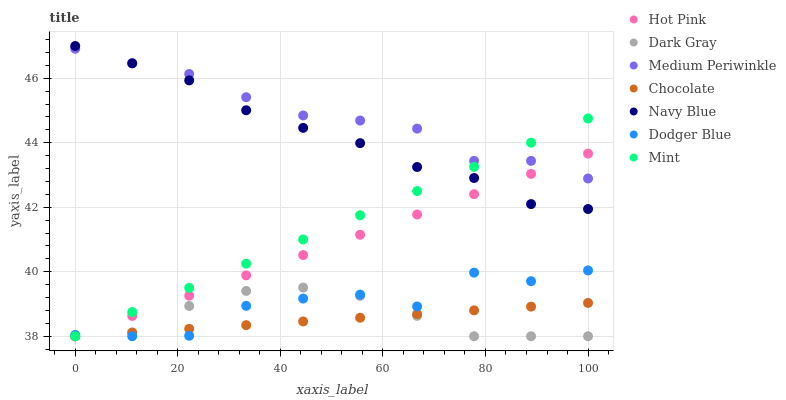Does Chocolate have the minimum area under the curve?
Answer yes or no. Yes. Does Medium Periwinkle have the maximum area under the curve?
Answer yes or no. Yes. Does Hot Pink have the minimum area under the curve?
Answer yes or no. No. Does Hot Pink have the maximum area under the curve?
Answer yes or no. No. Is Chocolate the smoothest?
Answer yes or no. Yes. Is Dodger Blue the roughest?
Answer yes or no. Yes. Is Hot Pink the smoothest?
Answer yes or no. No. Is Hot Pink the roughest?
Answer yes or no. No. Does Hot Pink have the lowest value?
Answer yes or no. Yes. Does Medium Periwinkle have the lowest value?
Answer yes or no. No. Does Navy Blue have the highest value?
Answer yes or no. Yes. Does Hot Pink have the highest value?
Answer yes or no. No. Is Dark Gray less than Medium Periwinkle?
Answer yes or no. Yes. Is Medium Periwinkle greater than Chocolate?
Answer yes or no. Yes. Does Navy Blue intersect Medium Periwinkle?
Answer yes or no. Yes. Is Navy Blue less than Medium Periwinkle?
Answer yes or no. No. Is Navy Blue greater than Medium Periwinkle?
Answer yes or no. No. Does Dark Gray intersect Medium Periwinkle?
Answer yes or no. No. 